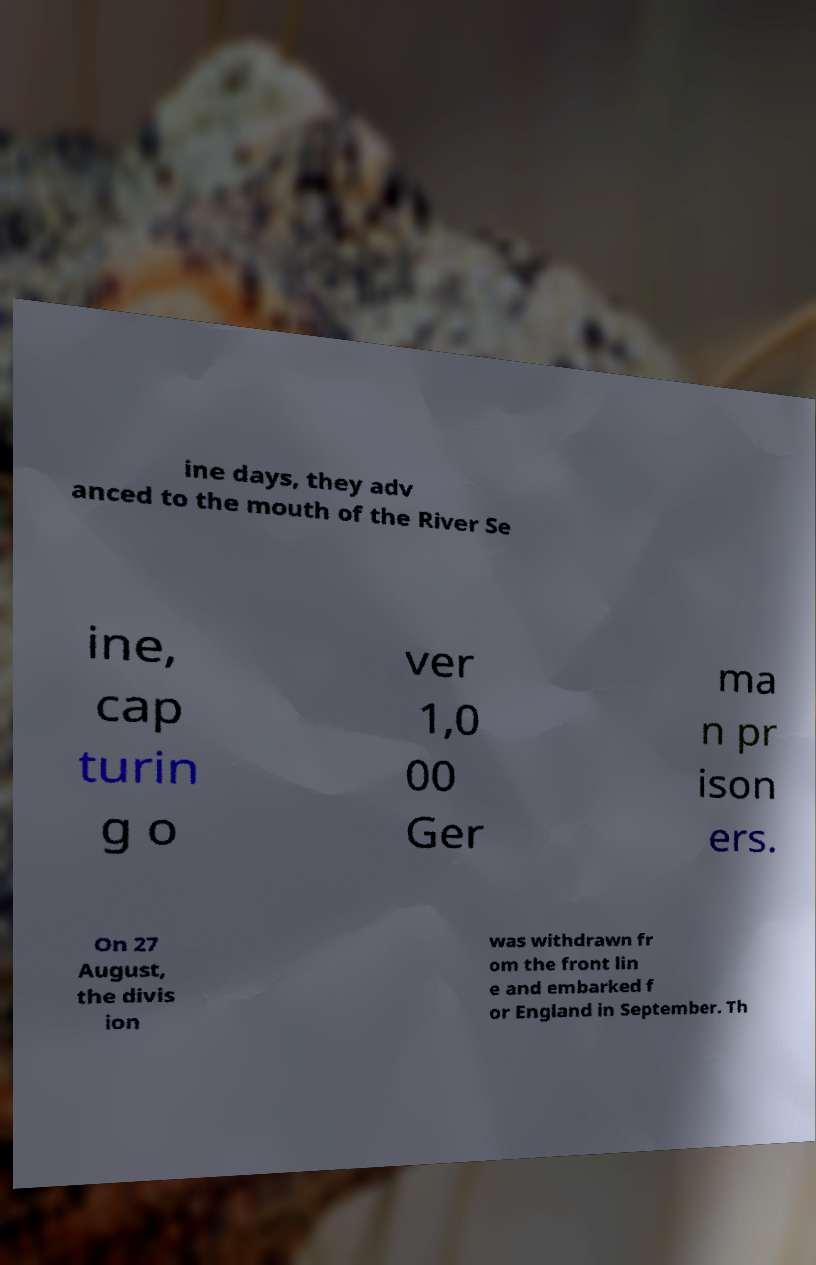Could you assist in decoding the text presented in this image and type it out clearly? ine days, they adv anced to the mouth of the River Se ine, cap turin g o ver 1,0 00 Ger ma n pr ison ers. On 27 August, the divis ion was withdrawn fr om the front lin e and embarked f or England in September. Th 